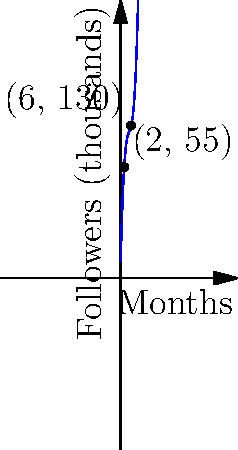A young football player's social media following is modeled by the function $f(x) = 0.5x^3 - 7.5x^2 + 40x + 10$, where $x$ represents the number of months since starting their professional career and $f(x)$ represents the number of followers in thousands. If the player currently has 130,000 followers, approximately how many more months will it take for their following to double? To solve this problem, we'll follow these steps:

1) First, we need to determine when the player has 130,000 followers. From the graph, we can see this occurs at $x = 6$ months.

2) We need to find when the player will have 260,000 followers (double 130,000).

3) We set up the equation:
   $0.5x^3 - 7.5x^2 + 40x + 10 = 260$

4) This is a cubic equation that's difficult to solve analytically. We can use a graphing calculator or numerical methods to find that the solution is approximately $x = 9.8$ months.

5) Since the player is currently at 6 months, we subtract:
   $9.8 - 6 = 3.8$ months

6) Rounding to the nearest month, it will take approximately 4 more months for the player's following to double.

This rapid growth in followers over a short period demonstrates the potential value of endorsing this young player early in their career.
Answer: 4 months 